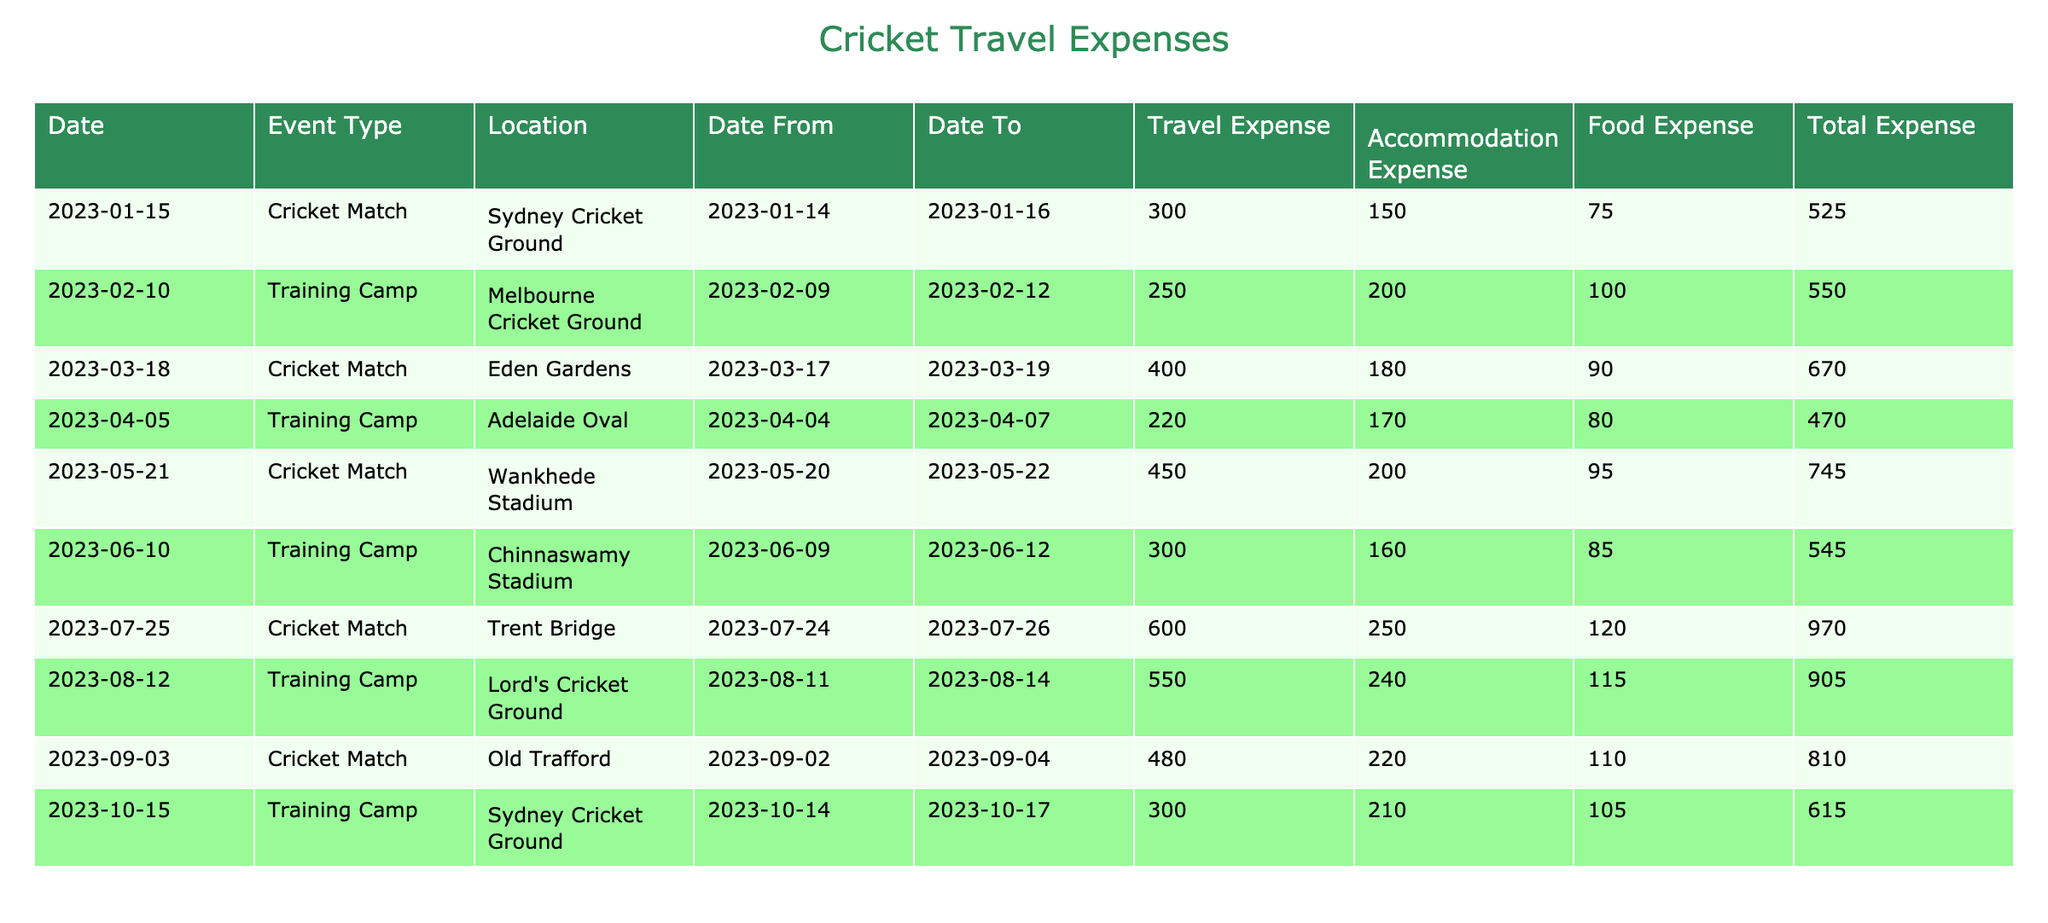What is the total expense for the Training Camp at Lord's Cricket Ground? The entry for the Training Camp at Lord's Cricket Ground shows a Total Expense of 905.
Answer: 905 What is the Travel Expense for the Cricket Match held at Old Trafford? The entry for the Cricket Match at Old Trafford lists the Travel Expense as 480.
Answer: 480 Which event had the highest Total Expense? The maximum Total Expense among all entries is 970 for the Cricket Match at Trent Bridge.
Answer: Trent Bridge What is the average Food Expense across all events? The Food Expenses for each event are 75, 100, 90, 80, 95, 85, 120, 115, 110, and 105. Summing these gives 1,085 and dividing by 10 results in an average of 108.5.
Answer: 108.5 Did the Training Camp at Adelaide Oval incur more expenses than the one at Chinnaswamy Stadium? The Total Expense for the Training Camp at Adelaide Oval is 470, while for Chinnaswamy Stadium, it is 545. Therefore, the expenditure at Adelaide Oval is less than at Chinnaswamy Stadium.
Answer: No What is the difference between the Total Expenses of the Cricket Match in Sydney and the Cricket Match in Wankhede Stadium? The Total Expense for the Cricket Match in Sydney is 525 and in Wankhede Stadium is 745. The difference is 745 - 525 = 220.
Answer: 220 What is the cumulative Travel Expense for all Training Camps? The Travel Expenses for the Training Camps are 250, 220, 300, and 550. Adding them gives 250 + 220 + 300 + 550 = 1320.
Answer: 1320 Is the Accommodation Expense for the Cricket Match at Eden Gardens higher than that for the Training Camp in Sydney? The Accommodation Expense for Eden Gardens is 180 and for Sydney is 150. Since 180 is greater than 150, the statement is true.
Answer: Yes What was the total amount spent on Travel Expenses for events in the month of April? In April, there is one Training Camp where the Travel Expense is 220. Hence, the total is 220.
Answer: 220 